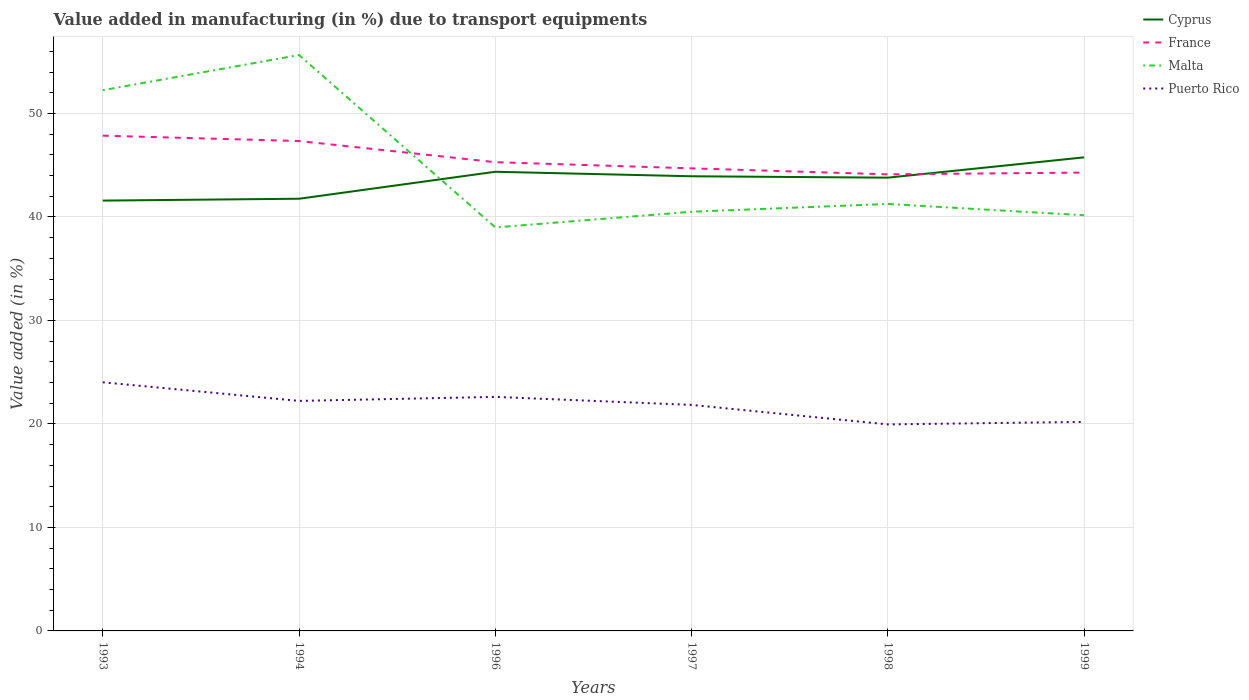Does the line corresponding to Malta intersect with the line corresponding to Cyprus?
Your answer should be compact. Yes. Across all years, what is the maximum percentage of value added in manufacturing due to transport equipments in France?
Provide a succinct answer. 44.12. What is the total percentage of value added in manufacturing due to transport equipments in Puerto Rico in the graph?
Your answer should be very brief. -0.24. What is the difference between the highest and the second highest percentage of value added in manufacturing due to transport equipments in Malta?
Your response must be concise. 16.66. How many lines are there?
Offer a terse response. 4. How many years are there in the graph?
Make the answer very short. 6. Are the values on the major ticks of Y-axis written in scientific E-notation?
Ensure brevity in your answer.  No. Does the graph contain any zero values?
Ensure brevity in your answer.  No. Does the graph contain grids?
Provide a short and direct response. Yes. How many legend labels are there?
Make the answer very short. 4. What is the title of the graph?
Make the answer very short. Value added in manufacturing (in %) due to transport equipments. What is the label or title of the Y-axis?
Ensure brevity in your answer.  Value added (in %). What is the Value added (in %) of Cyprus in 1993?
Offer a very short reply. 41.58. What is the Value added (in %) in France in 1993?
Make the answer very short. 47.86. What is the Value added (in %) in Malta in 1993?
Ensure brevity in your answer.  52.25. What is the Value added (in %) of Puerto Rico in 1993?
Make the answer very short. 24.03. What is the Value added (in %) of Cyprus in 1994?
Offer a terse response. 41.76. What is the Value added (in %) in France in 1994?
Give a very brief answer. 47.34. What is the Value added (in %) of Malta in 1994?
Your answer should be compact. 55.65. What is the Value added (in %) of Puerto Rico in 1994?
Your response must be concise. 22.23. What is the Value added (in %) of Cyprus in 1996?
Ensure brevity in your answer.  44.37. What is the Value added (in %) of France in 1996?
Your response must be concise. 45.29. What is the Value added (in %) of Malta in 1996?
Your response must be concise. 38.99. What is the Value added (in %) in Puerto Rico in 1996?
Offer a very short reply. 22.62. What is the Value added (in %) of Cyprus in 1997?
Keep it short and to the point. 43.93. What is the Value added (in %) of France in 1997?
Provide a succinct answer. 44.7. What is the Value added (in %) of Malta in 1997?
Ensure brevity in your answer.  40.5. What is the Value added (in %) of Puerto Rico in 1997?
Your answer should be very brief. 21.84. What is the Value added (in %) of Cyprus in 1998?
Provide a short and direct response. 43.8. What is the Value added (in %) of France in 1998?
Ensure brevity in your answer.  44.12. What is the Value added (in %) of Malta in 1998?
Your answer should be very brief. 41.26. What is the Value added (in %) in Puerto Rico in 1998?
Give a very brief answer. 19.95. What is the Value added (in %) of Cyprus in 1999?
Provide a short and direct response. 45.76. What is the Value added (in %) of France in 1999?
Your response must be concise. 44.29. What is the Value added (in %) in Malta in 1999?
Your answer should be very brief. 40.16. What is the Value added (in %) in Puerto Rico in 1999?
Provide a short and direct response. 20.2. Across all years, what is the maximum Value added (in %) in Cyprus?
Make the answer very short. 45.76. Across all years, what is the maximum Value added (in %) of France?
Your response must be concise. 47.86. Across all years, what is the maximum Value added (in %) in Malta?
Give a very brief answer. 55.65. Across all years, what is the maximum Value added (in %) in Puerto Rico?
Offer a terse response. 24.03. Across all years, what is the minimum Value added (in %) of Cyprus?
Make the answer very short. 41.58. Across all years, what is the minimum Value added (in %) of France?
Ensure brevity in your answer.  44.12. Across all years, what is the minimum Value added (in %) of Malta?
Provide a succinct answer. 38.99. Across all years, what is the minimum Value added (in %) in Puerto Rico?
Make the answer very short. 19.95. What is the total Value added (in %) in Cyprus in the graph?
Make the answer very short. 261.21. What is the total Value added (in %) of France in the graph?
Give a very brief answer. 273.6. What is the total Value added (in %) in Malta in the graph?
Your answer should be very brief. 268.81. What is the total Value added (in %) in Puerto Rico in the graph?
Make the answer very short. 130.86. What is the difference between the Value added (in %) of Cyprus in 1993 and that in 1994?
Offer a very short reply. -0.18. What is the difference between the Value added (in %) of France in 1993 and that in 1994?
Provide a succinct answer. 0.52. What is the difference between the Value added (in %) in Malta in 1993 and that in 1994?
Your answer should be very brief. -3.4. What is the difference between the Value added (in %) of Puerto Rico in 1993 and that in 1994?
Your response must be concise. 1.8. What is the difference between the Value added (in %) of Cyprus in 1993 and that in 1996?
Provide a short and direct response. -2.79. What is the difference between the Value added (in %) in France in 1993 and that in 1996?
Your answer should be very brief. 2.56. What is the difference between the Value added (in %) of Malta in 1993 and that in 1996?
Offer a terse response. 13.26. What is the difference between the Value added (in %) in Puerto Rico in 1993 and that in 1996?
Offer a very short reply. 1.41. What is the difference between the Value added (in %) of Cyprus in 1993 and that in 1997?
Give a very brief answer. -2.35. What is the difference between the Value added (in %) of France in 1993 and that in 1997?
Your answer should be compact. 3.16. What is the difference between the Value added (in %) of Malta in 1993 and that in 1997?
Offer a terse response. 11.75. What is the difference between the Value added (in %) in Puerto Rico in 1993 and that in 1997?
Give a very brief answer. 2.19. What is the difference between the Value added (in %) of Cyprus in 1993 and that in 1998?
Make the answer very short. -2.22. What is the difference between the Value added (in %) of France in 1993 and that in 1998?
Offer a terse response. 3.74. What is the difference between the Value added (in %) of Malta in 1993 and that in 1998?
Offer a terse response. 10.99. What is the difference between the Value added (in %) in Puerto Rico in 1993 and that in 1998?
Give a very brief answer. 4.07. What is the difference between the Value added (in %) in Cyprus in 1993 and that in 1999?
Provide a short and direct response. -4.18. What is the difference between the Value added (in %) of France in 1993 and that in 1999?
Offer a terse response. 3.57. What is the difference between the Value added (in %) of Malta in 1993 and that in 1999?
Your answer should be compact. 12.09. What is the difference between the Value added (in %) in Puerto Rico in 1993 and that in 1999?
Offer a terse response. 3.83. What is the difference between the Value added (in %) of Cyprus in 1994 and that in 1996?
Provide a short and direct response. -2.61. What is the difference between the Value added (in %) of France in 1994 and that in 1996?
Ensure brevity in your answer.  2.05. What is the difference between the Value added (in %) of Malta in 1994 and that in 1996?
Your answer should be compact. 16.66. What is the difference between the Value added (in %) in Puerto Rico in 1994 and that in 1996?
Provide a short and direct response. -0.39. What is the difference between the Value added (in %) in Cyprus in 1994 and that in 1997?
Your answer should be very brief. -2.17. What is the difference between the Value added (in %) in France in 1994 and that in 1997?
Your answer should be compact. 2.64. What is the difference between the Value added (in %) of Malta in 1994 and that in 1997?
Your response must be concise. 15.14. What is the difference between the Value added (in %) in Puerto Rico in 1994 and that in 1997?
Your response must be concise. 0.39. What is the difference between the Value added (in %) in Cyprus in 1994 and that in 1998?
Make the answer very short. -2.04. What is the difference between the Value added (in %) of France in 1994 and that in 1998?
Provide a short and direct response. 3.22. What is the difference between the Value added (in %) of Malta in 1994 and that in 1998?
Your answer should be compact. 14.39. What is the difference between the Value added (in %) in Puerto Rico in 1994 and that in 1998?
Offer a very short reply. 2.27. What is the difference between the Value added (in %) in Cyprus in 1994 and that in 1999?
Your answer should be very brief. -4. What is the difference between the Value added (in %) in France in 1994 and that in 1999?
Offer a very short reply. 3.05. What is the difference between the Value added (in %) of Malta in 1994 and that in 1999?
Your answer should be compact. 15.48. What is the difference between the Value added (in %) of Puerto Rico in 1994 and that in 1999?
Keep it short and to the point. 2.03. What is the difference between the Value added (in %) in Cyprus in 1996 and that in 1997?
Ensure brevity in your answer.  0.44. What is the difference between the Value added (in %) in France in 1996 and that in 1997?
Your answer should be compact. 0.6. What is the difference between the Value added (in %) in Malta in 1996 and that in 1997?
Give a very brief answer. -1.51. What is the difference between the Value added (in %) of Puerto Rico in 1996 and that in 1997?
Your response must be concise. 0.78. What is the difference between the Value added (in %) in Cyprus in 1996 and that in 1998?
Offer a very short reply. 0.57. What is the difference between the Value added (in %) in France in 1996 and that in 1998?
Offer a very short reply. 1.18. What is the difference between the Value added (in %) of Malta in 1996 and that in 1998?
Your answer should be very brief. -2.27. What is the difference between the Value added (in %) in Puerto Rico in 1996 and that in 1998?
Offer a terse response. 2.66. What is the difference between the Value added (in %) in Cyprus in 1996 and that in 1999?
Keep it short and to the point. -1.39. What is the difference between the Value added (in %) of France in 1996 and that in 1999?
Ensure brevity in your answer.  1. What is the difference between the Value added (in %) of Malta in 1996 and that in 1999?
Ensure brevity in your answer.  -1.17. What is the difference between the Value added (in %) of Puerto Rico in 1996 and that in 1999?
Make the answer very short. 2.42. What is the difference between the Value added (in %) of Cyprus in 1997 and that in 1998?
Offer a very short reply. 0.13. What is the difference between the Value added (in %) of France in 1997 and that in 1998?
Offer a terse response. 0.58. What is the difference between the Value added (in %) of Malta in 1997 and that in 1998?
Offer a very short reply. -0.75. What is the difference between the Value added (in %) in Puerto Rico in 1997 and that in 1998?
Make the answer very short. 1.88. What is the difference between the Value added (in %) in Cyprus in 1997 and that in 1999?
Your answer should be compact. -1.83. What is the difference between the Value added (in %) in France in 1997 and that in 1999?
Provide a short and direct response. 0.41. What is the difference between the Value added (in %) of Malta in 1997 and that in 1999?
Give a very brief answer. 0.34. What is the difference between the Value added (in %) in Puerto Rico in 1997 and that in 1999?
Give a very brief answer. 1.64. What is the difference between the Value added (in %) of Cyprus in 1998 and that in 1999?
Make the answer very short. -1.96. What is the difference between the Value added (in %) of France in 1998 and that in 1999?
Offer a very short reply. -0.17. What is the difference between the Value added (in %) of Malta in 1998 and that in 1999?
Give a very brief answer. 1.09. What is the difference between the Value added (in %) in Puerto Rico in 1998 and that in 1999?
Keep it short and to the point. -0.24. What is the difference between the Value added (in %) of Cyprus in 1993 and the Value added (in %) of France in 1994?
Offer a terse response. -5.76. What is the difference between the Value added (in %) of Cyprus in 1993 and the Value added (in %) of Malta in 1994?
Your response must be concise. -14.06. What is the difference between the Value added (in %) in Cyprus in 1993 and the Value added (in %) in Puerto Rico in 1994?
Your answer should be compact. 19.36. What is the difference between the Value added (in %) of France in 1993 and the Value added (in %) of Malta in 1994?
Make the answer very short. -7.79. What is the difference between the Value added (in %) of France in 1993 and the Value added (in %) of Puerto Rico in 1994?
Give a very brief answer. 25.63. What is the difference between the Value added (in %) of Malta in 1993 and the Value added (in %) of Puerto Rico in 1994?
Ensure brevity in your answer.  30.02. What is the difference between the Value added (in %) of Cyprus in 1993 and the Value added (in %) of France in 1996?
Keep it short and to the point. -3.71. What is the difference between the Value added (in %) in Cyprus in 1993 and the Value added (in %) in Malta in 1996?
Your answer should be compact. 2.59. What is the difference between the Value added (in %) in Cyprus in 1993 and the Value added (in %) in Puerto Rico in 1996?
Offer a very short reply. 18.97. What is the difference between the Value added (in %) of France in 1993 and the Value added (in %) of Malta in 1996?
Your response must be concise. 8.87. What is the difference between the Value added (in %) of France in 1993 and the Value added (in %) of Puerto Rico in 1996?
Your answer should be compact. 25.24. What is the difference between the Value added (in %) in Malta in 1993 and the Value added (in %) in Puerto Rico in 1996?
Give a very brief answer. 29.64. What is the difference between the Value added (in %) of Cyprus in 1993 and the Value added (in %) of France in 1997?
Your response must be concise. -3.11. What is the difference between the Value added (in %) of Cyprus in 1993 and the Value added (in %) of Malta in 1997?
Make the answer very short. 1.08. What is the difference between the Value added (in %) in Cyprus in 1993 and the Value added (in %) in Puerto Rico in 1997?
Your response must be concise. 19.74. What is the difference between the Value added (in %) of France in 1993 and the Value added (in %) of Malta in 1997?
Keep it short and to the point. 7.35. What is the difference between the Value added (in %) of France in 1993 and the Value added (in %) of Puerto Rico in 1997?
Provide a short and direct response. 26.02. What is the difference between the Value added (in %) in Malta in 1993 and the Value added (in %) in Puerto Rico in 1997?
Offer a terse response. 30.41. What is the difference between the Value added (in %) in Cyprus in 1993 and the Value added (in %) in France in 1998?
Your answer should be very brief. -2.54. What is the difference between the Value added (in %) of Cyprus in 1993 and the Value added (in %) of Malta in 1998?
Your response must be concise. 0.33. What is the difference between the Value added (in %) of Cyprus in 1993 and the Value added (in %) of Puerto Rico in 1998?
Keep it short and to the point. 21.63. What is the difference between the Value added (in %) of France in 1993 and the Value added (in %) of Puerto Rico in 1998?
Offer a very short reply. 27.9. What is the difference between the Value added (in %) of Malta in 1993 and the Value added (in %) of Puerto Rico in 1998?
Give a very brief answer. 32.3. What is the difference between the Value added (in %) in Cyprus in 1993 and the Value added (in %) in France in 1999?
Make the answer very short. -2.71. What is the difference between the Value added (in %) in Cyprus in 1993 and the Value added (in %) in Malta in 1999?
Your answer should be very brief. 1.42. What is the difference between the Value added (in %) of Cyprus in 1993 and the Value added (in %) of Puerto Rico in 1999?
Keep it short and to the point. 21.38. What is the difference between the Value added (in %) in France in 1993 and the Value added (in %) in Malta in 1999?
Provide a short and direct response. 7.69. What is the difference between the Value added (in %) of France in 1993 and the Value added (in %) of Puerto Rico in 1999?
Your response must be concise. 27.66. What is the difference between the Value added (in %) in Malta in 1993 and the Value added (in %) in Puerto Rico in 1999?
Provide a succinct answer. 32.05. What is the difference between the Value added (in %) in Cyprus in 1994 and the Value added (in %) in France in 1996?
Ensure brevity in your answer.  -3.53. What is the difference between the Value added (in %) in Cyprus in 1994 and the Value added (in %) in Malta in 1996?
Your answer should be very brief. 2.77. What is the difference between the Value added (in %) of Cyprus in 1994 and the Value added (in %) of Puerto Rico in 1996?
Your answer should be compact. 19.15. What is the difference between the Value added (in %) of France in 1994 and the Value added (in %) of Malta in 1996?
Your response must be concise. 8.35. What is the difference between the Value added (in %) in France in 1994 and the Value added (in %) in Puerto Rico in 1996?
Provide a short and direct response. 24.72. What is the difference between the Value added (in %) in Malta in 1994 and the Value added (in %) in Puerto Rico in 1996?
Offer a terse response. 33.03. What is the difference between the Value added (in %) of Cyprus in 1994 and the Value added (in %) of France in 1997?
Give a very brief answer. -2.94. What is the difference between the Value added (in %) in Cyprus in 1994 and the Value added (in %) in Malta in 1997?
Offer a very short reply. 1.26. What is the difference between the Value added (in %) of Cyprus in 1994 and the Value added (in %) of Puerto Rico in 1997?
Give a very brief answer. 19.92. What is the difference between the Value added (in %) in France in 1994 and the Value added (in %) in Malta in 1997?
Your answer should be very brief. 6.84. What is the difference between the Value added (in %) of France in 1994 and the Value added (in %) of Puerto Rico in 1997?
Offer a terse response. 25.5. What is the difference between the Value added (in %) of Malta in 1994 and the Value added (in %) of Puerto Rico in 1997?
Offer a very short reply. 33.81. What is the difference between the Value added (in %) in Cyprus in 1994 and the Value added (in %) in France in 1998?
Ensure brevity in your answer.  -2.36. What is the difference between the Value added (in %) in Cyprus in 1994 and the Value added (in %) in Malta in 1998?
Your answer should be very brief. 0.5. What is the difference between the Value added (in %) of Cyprus in 1994 and the Value added (in %) of Puerto Rico in 1998?
Make the answer very short. 21.81. What is the difference between the Value added (in %) in France in 1994 and the Value added (in %) in Malta in 1998?
Your answer should be very brief. 6.08. What is the difference between the Value added (in %) in France in 1994 and the Value added (in %) in Puerto Rico in 1998?
Provide a short and direct response. 27.39. What is the difference between the Value added (in %) of Malta in 1994 and the Value added (in %) of Puerto Rico in 1998?
Make the answer very short. 35.69. What is the difference between the Value added (in %) in Cyprus in 1994 and the Value added (in %) in France in 1999?
Ensure brevity in your answer.  -2.53. What is the difference between the Value added (in %) in Cyprus in 1994 and the Value added (in %) in Malta in 1999?
Your answer should be very brief. 1.6. What is the difference between the Value added (in %) in Cyprus in 1994 and the Value added (in %) in Puerto Rico in 1999?
Make the answer very short. 21.56. What is the difference between the Value added (in %) of France in 1994 and the Value added (in %) of Malta in 1999?
Provide a short and direct response. 7.18. What is the difference between the Value added (in %) in France in 1994 and the Value added (in %) in Puerto Rico in 1999?
Keep it short and to the point. 27.14. What is the difference between the Value added (in %) in Malta in 1994 and the Value added (in %) in Puerto Rico in 1999?
Your answer should be compact. 35.45. What is the difference between the Value added (in %) in Cyprus in 1996 and the Value added (in %) in France in 1997?
Your answer should be compact. -0.33. What is the difference between the Value added (in %) in Cyprus in 1996 and the Value added (in %) in Malta in 1997?
Provide a succinct answer. 3.86. What is the difference between the Value added (in %) in Cyprus in 1996 and the Value added (in %) in Puerto Rico in 1997?
Your answer should be very brief. 22.53. What is the difference between the Value added (in %) in France in 1996 and the Value added (in %) in Malta in 1997?
Ensure brevity in your answer.  4.79. What is the difference between the Value added (in %) in France in 1996 and the Value added (in %) in Puerto Rico in 1997?
Provide a short and direct response. 23.45. What is the difference between the Value added (in %) of Malta in 1996 and the Value added (in %) of Puerto Rico in 1997?
Provide a short and direct response. 17.15. What is the difference between the Value added (in %) in Cyprus in 1996 and the Value added (in %) in France in 1998?
Provide a succinct answer. 0.25. What is the difference between the Value added (in %) in Cyprus in 1996 and the Value added (in %) in Malta in 1998?
Provide a short and direct response. 3.11. What is the difference between the Value added (in %) in Cyprus in 1996 and the Value added (in %) in Puerto Rico in 1998?
Your answer should be very brief. 24.41. What is the difference between the Value added (in %) in France in 1996 and the Value added (in %) in Malta in 1998?
Provide a succinct answer. 4.04. What is the difference between the Value added (in %) in France in 1996 and the Value added (in %) in Puerto Rico in 1998?
Your answer should be very brief. 25.34. What is the difference between the Value added (in %) of Malta in 1996 and the Value added (in %) of Puerto Rico in 1998?
Provide a succinct answer. 19.04. What is the difference between the Value added (in %) of Cyprus in 1996 and the Value added (in %) of France in 1999?
Ensure brevity in your answer.  0.08. What is the difference between the Value added (in %) in Cyprus in 1996 and the Value added (in %) in Malta in 1999?
Provide a succinct answer. 4.2. What is the difference between the Value added (in %) in Cyprus in 1996 and the Value added (in %) in Puerto Rico in 1999?
Ensure brevity in your answer.  24.17. What is the difference between the Value added (in %) of France in 1996 and the Value added (in %) of Malta in 1999?
Make the answer very short. 5.13. What is the difference between the Value added (in %) in France in 1996 and the Value added (in %) in Puerto Rico in 1999?
Provide a succinct answer. 25.09. What is the difference between the Value added (in %) in Malta in 1996 and the Value added (in %) in Puerto Rico in 1999?
Your answer should be compact. 18.79. What is the difference between the Value added (in %) in Cyprus in 1997 and the Value added (in %) in France in 1998?
Provide a short and direct response. -0.19. What is the difference between the Value added (in %) in Cyprus in 1997 and the Value added (in %) in Malta in 1998?
Provide a short and direct response. 2.68. What is the difference between the Value added (in %) in Cyprus in 1997 and the Value added (in %) in Puerto Rico in 1998?
Your answer should be very brief. 23.98. What is the difference between the Value added (in %) of France in 1997 and the Value added (in %) of Malta in 1998?
Provide a short and direct response. 3.44. What is the difference between the Value added (in %) of France in 1997 and the Value added (in %) of Puerto Rico in 1998?
Ensure brevity in your answer.  24.74. What is the difference between the Value added (in %) of Malta in 1997 and the Value added (in %) of Puerto Rico in 1998?
Your answer should be very brief. 20.55. What is the difference between the Value added (in %) in Cyprus in 1997 and the Value added (in %) in France in 1999?
Offer a terse response. -0.36. What is the difference between the Value added (in %) of Cyprus in 1997 and the Value added (in %) of Malta in 1999?
Offer a very short reply. 3.77. What is the difference between the Value added (in %) in Cyprus in 1997 and the Value added (in %) in Puerto Rico in 1999?
Keep it short and to the point. 23.73. What is the difference between the Value added (in %) in France in 1997 and the Value added (in %) in Malta in 1999?
Offer a terse response. 4.53. What is the difference between the Value added (in %) in France in 1997 and the Value added (in %) in Puerto Rico in 1999?
Your answer should be compact. 24.5. What is the difference between the Value added (in %) of Malta in 1997 and the Value added (in %) of Puerto Rico in 1999?
Your answer should be very brief. 20.31. What is the difference between the Value added (in %) in Cyprus in 1998 and the Value added (in %) in France in 1999?
Provide a short and direct response. -0.49. What is the difference between the Value added (in %) in Cyprus in 1998 and the Value added (in %) in Malta in 1999?
Give a very brief answer. 3.63. What is the difference between the Value added (in %) in Cyprus in 1998 and the Value added (in %) in Puerto Rico in 1999?
Give a very brief answer. 23.6. What is the difference between the Value added (in %) of France in 1998 and the Value added (in %) of Malta in 1999?
Ensure brevity in your answer.  3.95. What is the difference between the Value added (in %) of France in 1998 and the Value added (in %) of Puerto Rico in 1999?
Your response must be concise. 23.92. What is the difference between the Value added (in %) in Malta in 1998 and the Value added (in %) in Puerto Rico in 1999?
Your response must be concise. 21.06. What is the average Value added (in %) in Cyprus per year?
Ensure brevity in your answer.  43.53. What is the average Value added (in %) in France per year?
Your answer should be very brief. 45.6. What is the average Value added (in %) in Malta per year?
Your answer should be very brief. 44.8. What is the average Value added (in %) of Puerto Rico per year?
Provide a short and direct response. 21.81. In the year 1993, what is the difference between the Value added (in %) of Cyprus and Value added (in %) of France?
Provide a succinct answer. -6.27. In the year 1993, what is the difference between the Value added (in %) of Cyprus and Value added (in %) of Malta?
Your response must be concise. -10.67. In the year 1993, what is the difference between the Value added (in %) in Cyprus and Value added (in %) in Puerto Rico?
Make the answer very short. 17.56. In the year 1993, what is the difference between the Value added (in %) in France and Value added (in %) in Malta?
Make the answer very short. -4.39. In the year 1993, what is the difference between the Value added (in %) in France and Value added (in %) in Puerto Rico?
Your response must be concise. 23.83. In the year 1993, what is the difference between the Value added (in %) of Malta and Value added (in %) of Puerto Rico?
Offer a terse response. 28.23. In the year 1994, what is the difference between the Value added (in %) of Cyprus and Value added (in %) of France?
Provide a short and direct response. -5.58. In the year 1994, what is the difference between the Value added (in %) in Cyprus and Value added (in %) in Malta?
Your response must be concise. -13.89. In the year 1994, what is the difference between the Value added (in %) in Cyprus and Value added (in %) in Puerto Rico?
Keep it short and to the point. 19.53. In the year 1994, what is the difference between the Value added (in %) of France and Value added (in %) of Malta?
Your answer should be very brief. -8.31. In the year 1994, what is the difference between the Value added (in %) of France and Value added (in %) of Puerto Rico?
Provide a short and direct response. 25.11. In the year 1994, what is the difference between the Value added (in %) of Malta and Value added (in %) of Puerto Rico?
Provide a short and direct response. 33.42. In the year 1996, what is the difference between the Value added (in %) of Cyprus and Value added (in %) of France?
Your answer should be compact. -0.93. In the year 1996, what is the difference between the Value added (in %) in Cyprus and Value added (in %) in Malta?
Ensure brevity in your answer.  5.38. In the year 1996, what is the difference between the Value added (in %) in Cyprus and Value added (in %) in Puerto Rico?
Your response must be concise. 21.75. In the year 1996, what is the difference between the Value added (in %) in France and Value added (in %) in Malta?
Provide a short and direct response. 6.3. In the year 1996, what is the difference between the Value added (in %) in France and Value added (in %) in Puerto Rico?
Give a very brief answer. 22.68. In the year 1996, what is the difference between the Value added (in %) of Malta and Value added (in %) of Puerto Rico?
Ensure brevity in your answer.  16.37. In the year 1997, what is the difference between the Value added (in %) in Cyprus and Value added (in %) in France?
Provide a succinct answer. -0.77. In the year 1997, what is the difference between the Value added (in %) of Cyprus and Value added (in %) of Malta?
Provide a succinct answer. 3.43. In the year 1997, what is the difference between the Value added (in %) of Cyprus and Value added (in %) of Puerto Rico?
Ensure brevity in your answer.  22.09. In the year 1997, what is the difference between the Value added (in %) of France and Value added (in %) of Malta?
Your answer should be very brief. 4.19. In the year 1997, what is the difference between the Value added (in %) of France and Value added (in %) of Puerto Rico?
Make the answer very short. 22.86. In the year 1997, what is the difference between the Value added (in %) in Malta and Value added (in %) in Puerto Rico?
Your answer should be compact. 18.66. In the year 1998, what is the difference between the Value added (in %) of Cyprus and Value added (in %) of France?
Offer a terse response. -0.32. In the year 1998, what is the difference between the Value added (in %) of Cyprus and Value added (in %) of Malta?
Offer a terse response. 2.54. In the year 1998, what is the difference between the Value added (in %) in Cyprus and Value added (in %) in Puerto Rico?
Keep it short and to the point. 23.84. In the year 1998, what is the difference between the Value added (in %) in France and Value added (in %) in Malta?
Make the answer very short. 2.86. In the year 1998, what is the difference between the Value added (in %) of France and Value added (in %) of Puerto Rico?
Keep it short and to the point. 24.16. In the year 1998, what is the difference between the Value added (in %) of Malta and Value added (in %) of Puerto Rico?
Provide a succinct answer. 21.3. In the year 1999, what is the difference between the Value added (in %) of Cyprus and Value added (in %) of France?
Your answer should be very brief. 1.47. In the year 1999, what is the difference between the Value added (in %) in Cyprus and Value added (in %) in Malta?
Offer a very short reply. 5.6. In the year 1999, what is the difference between the Value added (in %) of Cyprus and Value added (in %) of Puerto Rico?
Give a very brief answer. 25.56. In the year 1999, what is the difference between the Value added (in %) of France and Value added (in %) of Malta?
Make the answer very short. 4.12. In the year 1999, what is the difference between the Value added (in %) in France and Value added (in %) in Puerto Rico?
Your answer should be compact. 24.09. In the year 1999, what is the difference between the Value added (in %) of Malta and Value added (in %) of Puerto Rico?
Your answer should be very brief. 19.97. What is the ratio of the Value added (in %) of Cyprus in 1993 to that in 1994?
Give a very brief answer. 1. What is the ratio of the Value added (in %) in France in 1993 to that in 1994?
Your answer should be compact. 1.01. What is the ratio of the Value added (in %) of Malta in 1993 to that in 1994?
Offer a terse response. 0.94. What is the ratio of the Value added (in %) in Puerto Rico in 1993 to that in 1994?
Offer a terse response. 1.08. What is the ratio of the Value added (in %) of Cyprus in 1993 to that in 1996?
Keep it short and to the point. 0.94. What is the ratio of the Value added (in %) of France in 1993 to that in 1996?
Offer a very short reply. 1.06. What is the ratio of the Value added (in %) in Malta in 1993 to that in 1996?
Make the answer very short. 1.34. What is the ratio of the Value added (in %) of Puerto Rico in 1993 to that in 1996?
Provide a succinct answer. 1.06. What is the ratio of the Value added (in %) of Cyprus in 1993 to that in 1997?
Provide a short and direct response. 0.95. What is the ratio of the Value added (in %) of France in 1993 to that in 1997?
Offer a very short reply. 1.07. What is the ratio of the Value added (in %) of Malta in 1993 to that in 1997?
Provide a succinct answer. 1.29. What is the ratio of the Value added (in %) in Puerto Rico in 1993 to that in 1997?
Keep it short and to the point. 1.1. What is the ratio of the Value added (in %) in Cyprus in 1993 to that in 1998?
Your answer should be compact. 0.95. What is the ratio of the Value added (in %) in France in 1993 to that in 1998?
Offer a very short reply. 1.08. What is the ratio of the Value added (in %) in Malta in 1993 to that in 1998?
Provide a short and direct response. 1.27. What is the ratio of the Value added (in %) in Puerto Rico in 1993 to that in 1998?
Your answer should be compact. 1.2. What is the ratio of the Value added (in %) of Cyprus in 1993 to that in 1999?
Offer a very short reply. 0.91. What is the ratio of the Value added (in %) in France in 1993 to that in 1999?
Offer a very short reply. 1.08. What is the ratio of the Value added (in %) of Malta in 1993 to that in 1999?
Your answer should be very brief. 1.3. What is the ratio of the Value added (in %) of Puerto Rico in 1993 to that in 1999?
Provide a short and direct response. 1.19. What is the ratio of the Value added (in %) in France in 1994 to that in 1996?
Your answer should be very brief. 1.05. What is the ratio of the Value added (in %) in Malta in 1994 to that in 1996?
Provide a succinct answer. 1.43. What is the ratio of the Value added (in %) of Puerto Rico in 1994 to that in 1996?
Provide a short and direct response. 0.98. What is the ratio of the Value added (in %) of Cyprus in 1994 to that in 1997?
Your response must be concise. 0.95. What is the ratio of the Value added (in %) of France in 1994 to that in 1997?
Offer a terse response. 1.06. What is the ratio of the Value added (in %) in Malta in 1994 to that in 1997?
Your response must be concise. 1.37. What is the ratio of the Value added (in %) in Puerto Rico in 1994 to that in 1997?
Provide a short and direct response. 1.02. What is the ratio of the Value added (in %) in Cyprus in 1994 to that in 1998?
Your answer should be very brief. 0.95. What is the ratio of the Value added (in %) in France in 1994 to that in 1998?
Provide a succinct answer. 1.07. What is the ratio of the Value added (in %) in Malta in 1994 to that in 1998?
Keep it short and to the point. 1.35. What is the ratio of the Value added (in %) of Puerto Rico in 1994 to that in 1998?
Offer a terse response. 1.11. What is the ratio of the Value added (in %) of Cyprus in 1994 to that in 1999?
Provide a succinct answer. 0.91. What is the ratio of the Value added (in %) of France in 1994 to that in 1999?
Keep it short and to the point. 1.07. What is the ratio of the Value added (in %) of Malta in 1994 to that in 1999?
Your answer should be very brief. 1.39. What is the ratio of the Value added (in %) in Puerto Rico in 1994 to that in 1999?
Provide a succinct answer. 1.1. What is the ratio of the Value added (in %) in Cyprus in 1996 to that in 1997?
Your answer should be very brief. 1.01. What is the ratio of the Value added (in %) of France in 1996 to that in 1997?
Offer a terse response. 1.01. What is the ratio of the Value added (in %) of Malta in 1996 to that in 1997?
Offer a very short reply. 0.96. What is the ratio of the Value added (in %) of Puerto Rico in 1996 to that in 1997?
Ensure brevity in your answer.  1.04. What is the ratio of the Value added (in %) of Cyprus in 1996 to that in 1998?
Ensure brevity in your answer.  1.01. What is the ratio of the Value added (in %) in France in 1996 to that in 1998?
Offer a terse response. 1.03. What is the ratio of the Value added (in %) in Malta in 1996 to that in 1998?
Ensure brevity in your answer.  0.95. What is the ratio of the Value added (in %) of Puerto Rico in 1996 to that in 1998?
Offer a terse response. 1.13. What is the ratio of the Value added (in %) of Cyprus in 1996 to that in 1999?
Offer a very short reply. 0.97. What is the ratio of the Value added (in %) in France in 1996 to that in 1999?
Make the answer very short. 1.02. What is the ratio of the Value added (in %) of Malta in 1996 to that in 1999?
Give a very brief answer. 0.97. What is the ratio of the Value added (in %) of Puerto Rico in 1996 to that in 1999?
Offer a very short reply. 1.12. What is the ratio of the Value added (in %) of France in 1997 to that in 1998?
Your response must be concise. 1.01. What is the ratio of the Value added (in %) in Malta in 1997 to that in 1998?
Offer a very short reply. 0.98. What is the ratio of the Value added (in %) of Puerto Rico in 1997 to that in 1998?
Your answer should be very brief. 1.09. What is the ratio of the Value added (in %) of France in 1997 to that in 1999?
Offer a very short reply. 1.01. What is the ratio of the Value added (in %) of Malta in 1997 to that in 1999?
Provide a succinct answer. 1.01. What is the ratio of the Value added (in %) in Puerto Rico in 1997 to that in 1999?
Offer a very short reply. 1.08. What is the ratio of the Value added (in %) in Cyprus in 1998 to that in 1999?
Ensure brevity in your answer.  0.96. What is the ratio of the Value added (in %) in France in 1998 to that in 1999?
Make the answer very short. 1. What is the ratio of the Value added (in %) of Malta in 1998 to that in 1999?
Keep it short and to the point. 1.03. What is the ratio of the Value added (in %) in Puerto Rico in 1998 to that in 1999?
Offer a terse response. 0.99. What is the difference between the highest and the second highest Value added (in %) in Cyprus?
Your answer should be compact. 1.39. What is the difference between the highest and the second highest Value added (in %) in France?
Provide a short and direct response. 0.52. What is the difference between the highest and the second highest Value added (in %) in Malta?
Make the answer very short. 3.4. What is the difference between the highest and the second highest Value added (in %) of Puerto Rico?
Provide a short and direct response. 1.41. What is the difference between the highest and the lowest Value added (in %) in Cyprus?
Keep it short and to the point. 4.18. What is the difference between the highest and the lowest Value added (in %) of France?
Give a very brief answer. 3.74. What is the difference between the highest and the lowest Value added (in %) of Malta?
Your response must be concise. 16.66. What is the difference between the highest and the lowest Value added (in %) in Puerto Rico?
Give a very brief answer. 4.07. 